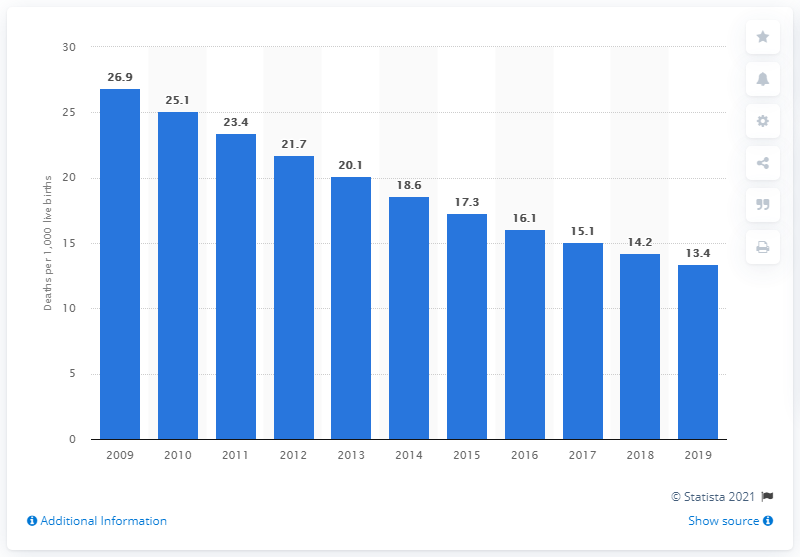Mention a couple of crucial points in this snapshot. According to data from 2019, the infant mortality rate in Mongolia was 13.4. 